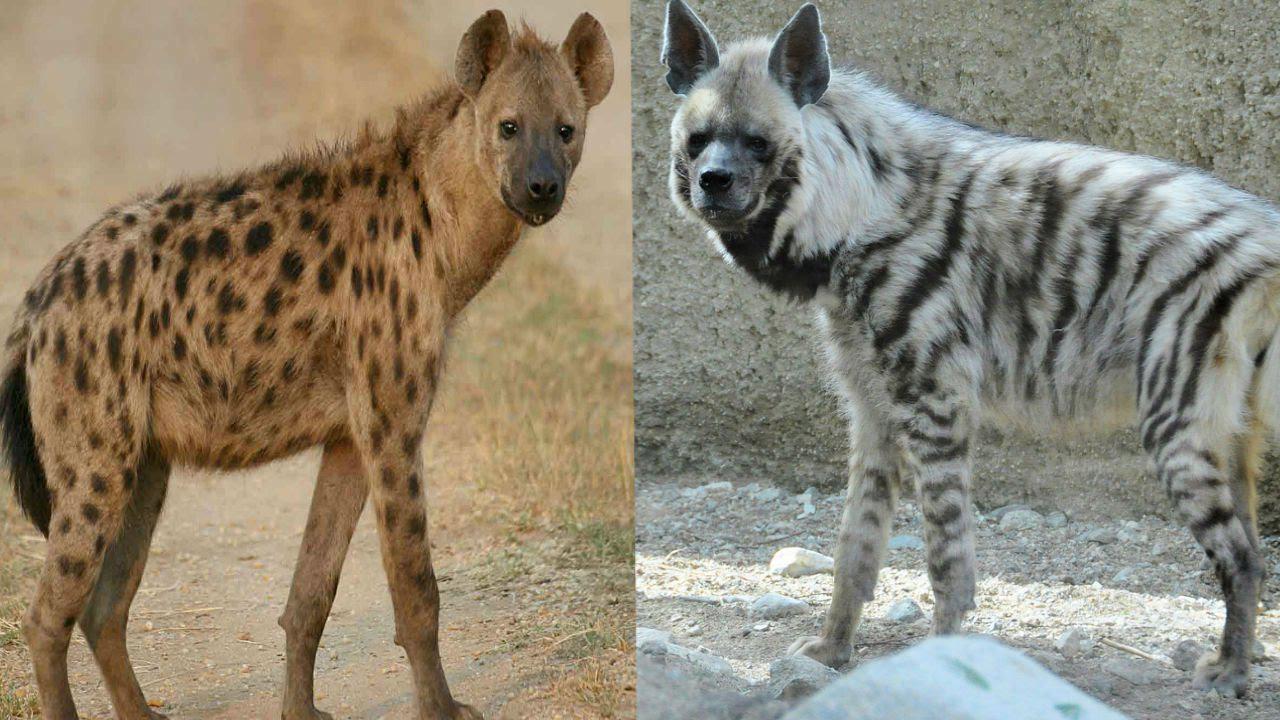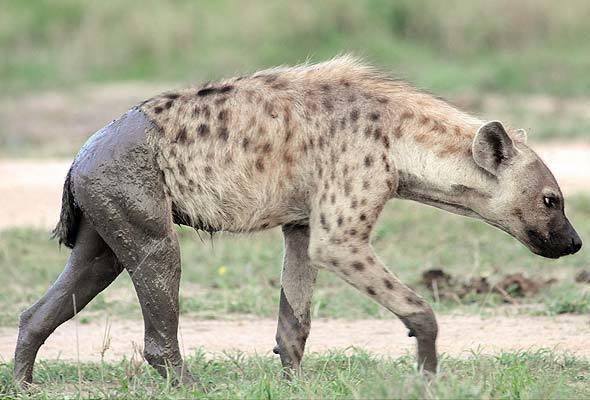The first image is the image on the left, the second image is the image on the right. Examine the images to the left and right. Is the description "A hyena has its mouth wide open" accurate? Answer yes or no. No. 